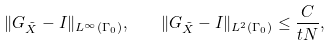Convert formula to latex. <formula><loc_0><loc_0><loc_500><loc_500>\| G _ { \tilde { X } } - I \| _ { L ^ { \infty } ( \Gamma _ { 0 } ) } , \quad \| G _ { \tilde { X } } - I \| _ { L ^ { 2 } ( \Gamma _ { 0 } ) } \leq \frac { C } { t N } ,</formula> 